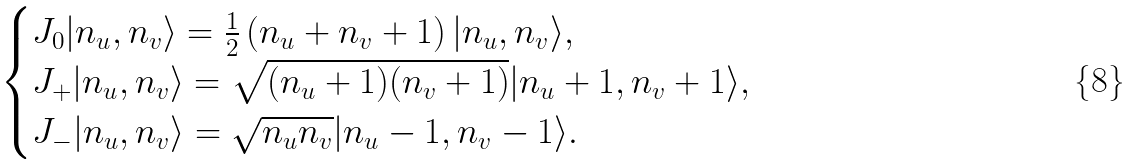Convert formula to latex. <formula><loc_0><loc_0><loc_500><loc_500>\begin{cases} J _ { 0 } | n _ { u } , n _ { v } \rangle = \frac { 1 } { 2 } \left ( n _ { u } + n _ { v } + 1 \right ) | n _ { u } , n _ { v } \rangle , \\ J _ { + } | n _ { u } , n _ { v } \rangle = \sqrt { ( n _ { u } + 1 ) ( n _ { v } + 1 ) } | n _ { u } + 1 , n _ { v } + 1 \rangle , \\ J _ { - } | n _ { u } , n _ { v } \rangle = \sqrt { n _ { u } n _ { v } } | n _ { u } - 1 , n _ { v } - 1 \rangle . \end{cases}</formula> 